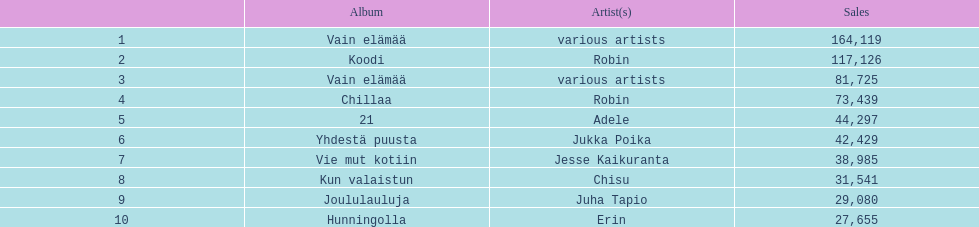Which collection has the largest number of sales without an assigned artist? Vain elämää. 